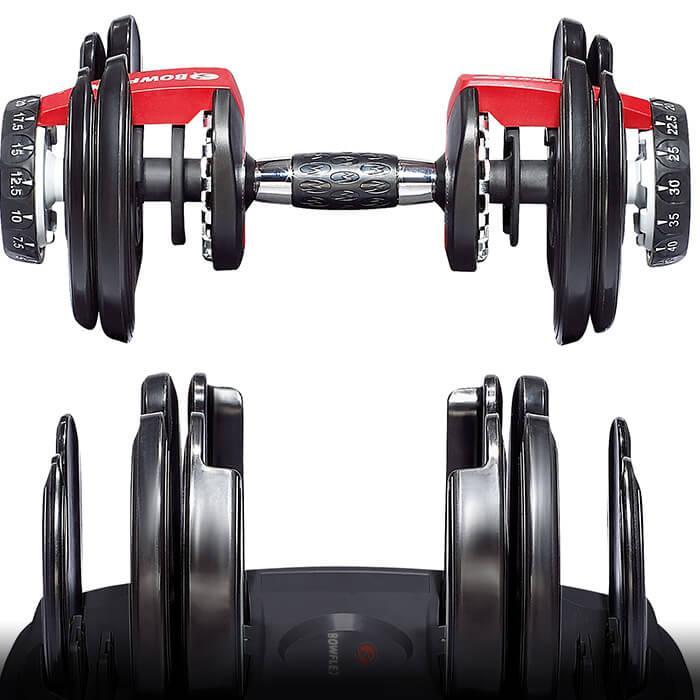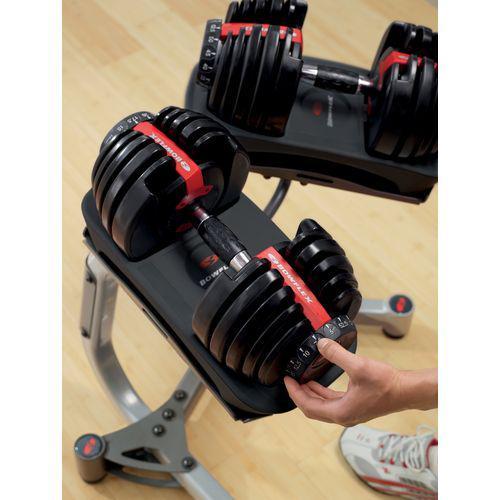The first image is the image on the left, the second image is the image on the right. Given the left and right images, does the statement "There is exactly one hand visible." hold true? Answer yes or no. Yes. The first image is the image on the left, the second image is the image on the right. Analyze the images presented: Is the assertion "There are three dumbbells." valid? Answer yes or no. Yes. 